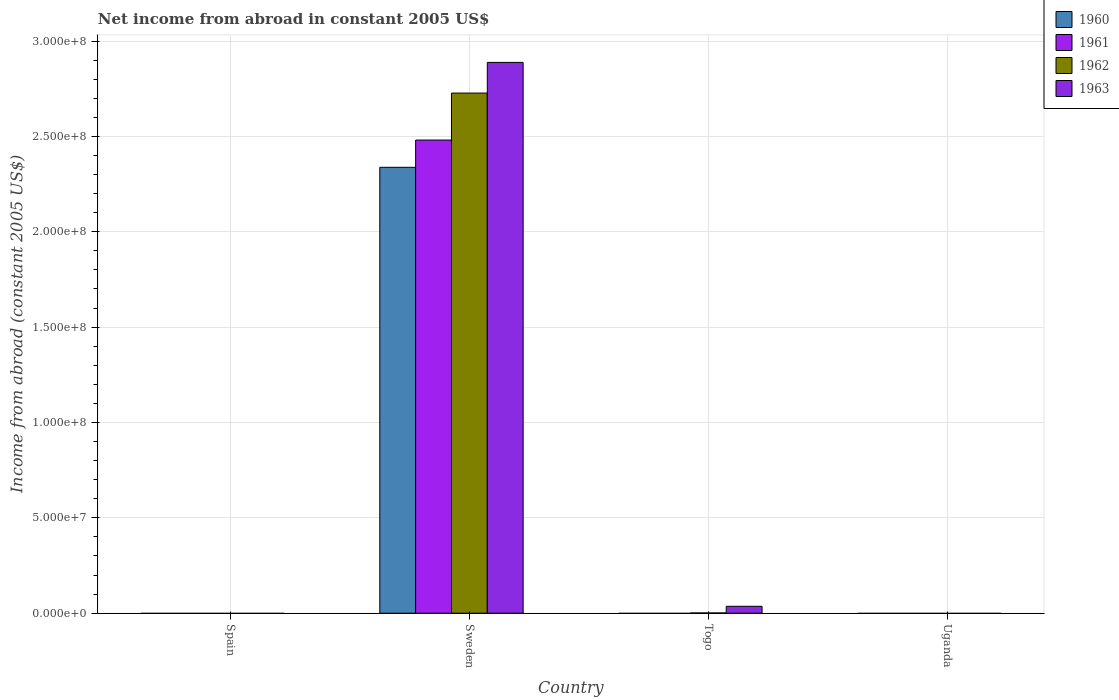How many different coloured bars are there?
Keep it short and to the point. 4. Are the number of bars on each tick of the X-axis equal?
Provide a short and direct response. No. How many bars are there on the 4th tick from the left?
Offer a very short reply. 0. How many bars are there on the 3rd tick from the right?
Your answer should be very brief. 4. What is the net income from abroad in 1963 in Sweden?
Your response must be concise. 2.89e+08. Across all countries, what is the maximum net income from abroad in 1960?
Provide a short and direct response. 2.34e+08. In which country was the net income from abroad in 1961 maximum?
Give a very brief answer. Sweden. What is the total net income from abroad in 1963 in the graph?
Ensure brevity in your answer.  2.92e+08. What is the difference between the net income from abroad in 1960 in Togo and the net income from abroad in 1962 in Sweden?
Offer a very short reply. -2.73e+08. What is the average net income from abroad in 1960 per country?
Offer a very short reply. 5.84e+07. What is the difference between the net income from abroad of/in 1961 and net income from abroad of/in 1963 in Sweden?
Make the answer very short. -4.07e+07. In how many countries, is the net income from abroad in 1962 greater than 60000000 US$?
Your answer should be compact. 1. What is the difference between the highest and the lowest net income from abroad in 1961?
Keep it short and to the point. 2.48e+08. Is it the case that in every country, the sum of the net income from abroad in 1961 and net income from abroad in 1963 is greater than the sum of net income from abroad in 1962 and net income from abroad in 1960?
Keep it short and to the point. No. Is it the case that in every country, the sum of the net income from abroad in 1963 and net income from abroad in 1960 is greater than the net income from abroad in 1961?
Provide a short and direct response. No. How many bars are there?
Keep it short and to the point. 6. Are all the bars in the graph horizontal?
Ensure brevity in your answer.  No. Are the values on the major ticks of Y-axis written in scientific E-notation?
Give a very brief answer. Yes. Does the graph contain grids?
Your answer should be compact. Yes. Where does the legend appear in the graph?
Your answer should be very brief. Top right. What is the title of the graph?
Your answer should be very brief. Net income from abroad in constant 2005 US$. What is the label or title of the Y-axis?
Your response must be concise. Income from abroad (constant 2005 US$). What is the Income from abroad (constant 2005 US$) of 1961 in Spain?
Provide a succinct answer. 0. What is the Income from abroad (constant 2005 US$) in 1963 in Spain?
Provide a short and direct response. 0. What is the Income from abroad (constant 2005 US$) of 1960 in Sweden?
Keep it short and to the point. 2.34e+08. What is the Income from abroad (constant 2005 US$) in 1961 in Sweden?
Provide a short and direct response. 2.48e+08. What is the Income from abroad (constant 2005 US$) in 1962 in Sweden?
Offer a very short reply. 2.73e+08. What is the Income from abroad (constant 2005 US$) of 1963 in Sweden?
Keep it short and to the point. 2.89e+08. What is the Income from abroad (constant 2005 US$) in 1960 in Togo?
Make the answer very short. 0. What is the Income from abroad (constant 2005 US$) in 1961 in Togo?
Give a very brief answer. 0. What is the Income from abroad (constant 2005 US$) of 1962 in Togo?
Provide a succinct answer. 1.22e+05. What is the Income from abroad (constant 2005 US$) of 1963 in Togo?
Your answer should be very brief. 3.62e+06. What is the Income from abroad (constant 2005 US$) in 1960 in Uganda?
Provide a short and direct response. 0. What is the Income from abroad (constant 2005 US$) of 1961 in Uganda?
Provide a short and direct response. 0. What is the Income from abroad (constant 2005 US$) of 1963 in Uganda?
Your response must be concise. 0. Across all countries, what is the maximum Income from abroad (constant 2005 US$) of 1960?
Provide a short and direct response. 2.34e+08. Across all countries, what is the maximum Income from abroad (constant 2005 US$) in 1961?
Your answer should be very brief. 2.48e+08. Across all countries, what is the maximum Income from abroad (constant 2005 US$) in 1962?
Your response must be concise. 2.73e+08. Across all countries, what is the maximum Income from abroad (constant 2005 US$) of 1963?
Offer a terse response. 2.89e+08. Across all countries, what is the minimum Income from abroad (constant 2005 US$) in 1960?
Provide a succinct answer. 0. Across all countries, what is the minimum Income from abroad (constant 2005 US$) of 1962?
Your answer should be very brief. 0. What is the total Income from abroad (constant 2005 US$) of 1960 in the graph?
Provide a succinct answer. 2.34e+08. What is the total Income from abroad (constant 2005 US$) in 1961 in the graph?
Offer a very short reply. 2.48e+08. What is the total Income from abroad (constant 2005 US$) of 1962 in the graph?
Make the answer very short. 2.73e+08. What is the total Income from abroad (constant 2005 US$) in 1963 in the graph?
Make the answer very short. 2.92e+08. What is the difference between the Income from abroad (constant 2005 US$) of 1962 in Sweden and that in Togo?
Offer a very short reply. 2.73e+08. What is the difference between the Income from abroad (constant 2005 US$) in 1963 in Sweden and that in Togo?
Ensure brevity in your answer.  2.85e+08. What is the difference between the Income from abroad (constant 2005 US$) of 1960 in Sweden and the Income from abroad (constant 2005 US$) of 1962 in Togo?
Offer a terse response. 2.34e+08. What is the difference between the Income from abroad (constant 2005 US$) in 1960 in Sweden and the Income from abroad (constant 2005 US$) in 1963 in Togo?
Keep it short and to the point. 2.30e+08. What is the difference between the Income from abroad (constant 2005 US$) in 1961 in Sweden and the Income from abroad (constant 2005 US$) in 1962 in Togo?
Provide a short and direct response. 2.48e+08. What is the difference between the Income from abroad (constant 2005 US$) in 1961 in Sweden and the Income from abroad (constant 2005 US$) in 1963 in Togo?
Offer a very short reply. 2.44e+08. What is the difference between the Income from abroad (constant 2005 US$) in 1962 in Sweden and the Income from abroad (constant 2005 US$) in 1963 in Togo?
Keep it short and to the point. 2.69e+08. What is the average Income from abroad (constant 2005 US$) in 1960 per country?
Offer a very short reply. 5.84e+07. What is the average Income from abroad (constant 2005 US$) of 1961 per country?
Offer a very short reply. 6.20e+07. What is the average Income from abroad (constant 2005 US$) in 1962 per country?
Your response must be concise. 6.82e+07. What is the average Income from abroad (constant 2005 US$) of 1963 per country?
Give a very brief answer. 7.31e+07. What is the difference between the Income from abroad (constant 2005 US$) in 1960 and Income from abroad (constant 2005 US$) in 1961 in Sweden?
Provide a short and direct response. -1.43e+07. What is the difference between the Income from abroad (constant 2005 US$) of 1960 and Income from abroad (constant 2005 US$) of 1962 in Sweden?
Ensure brevity in your answer.  -3.89e+07. What is the difference between the Income from abroad (constant 2005 US$) of 1960 and Income from abroad (constant 2005 US$) of 1963 in Sweden?
Provide a short and direct response. -5.50e+07. What is the difference between the Income from abroad (constant 2005 US$) of 1961 and Income from abroad (constant 2005 US$) of 1962 in Sweden?
Keep it short and to the point. -2.46e+07. What is the difference between the Income from abroad (constant 2005 US$) in 1961 and Income from abroad (constant 2005 US$) in 1963 in Sweden?
Your answer should be very brief. -4.07e+07. What is the difference between the Income from abroad (constant 2005 US$) of 1962 and Income from abroad (constant 2005 US$) of 1963 in Sweden?
Offer a very short reply. -1.61e+07. What is the difference between the Income from abroad (constant 2005 US$) in 1962 and Income from abroad (constant 2005 US$) in 1963 in Togo?
Provide a short and direct response. -3.50e+06. What is the ratio of the Income from abroad (constant 2005 US$) of 1962 in Sweden to that in Togo?
Your answer should be compact. 2230.99. What is the ratio of the Income from abroad (constant 2005 US$) in 1963 in Sweden to that in Togo?
Ensure brevity in your answer.  79.67. What is the difference between the highest and the lowest Income from abroad (constant 2005 US$) of 1960?
Your answer should be compact. 2.34e+08. What is the difference between the highest and the lowest Income from abroad (constant 2005 US$) in 1961?
Offer a terse response. 2.48e+08. What is the difference between the highest and the lowest Income from abroad (constant 2005 US$) in 1962?
Your response must be concise. 2.73e+08. What is the difference between the highest and the lowest Income from abroad (constant 2005 US$) of 1963?
Provide a short and direct response. 2.89e+08. 